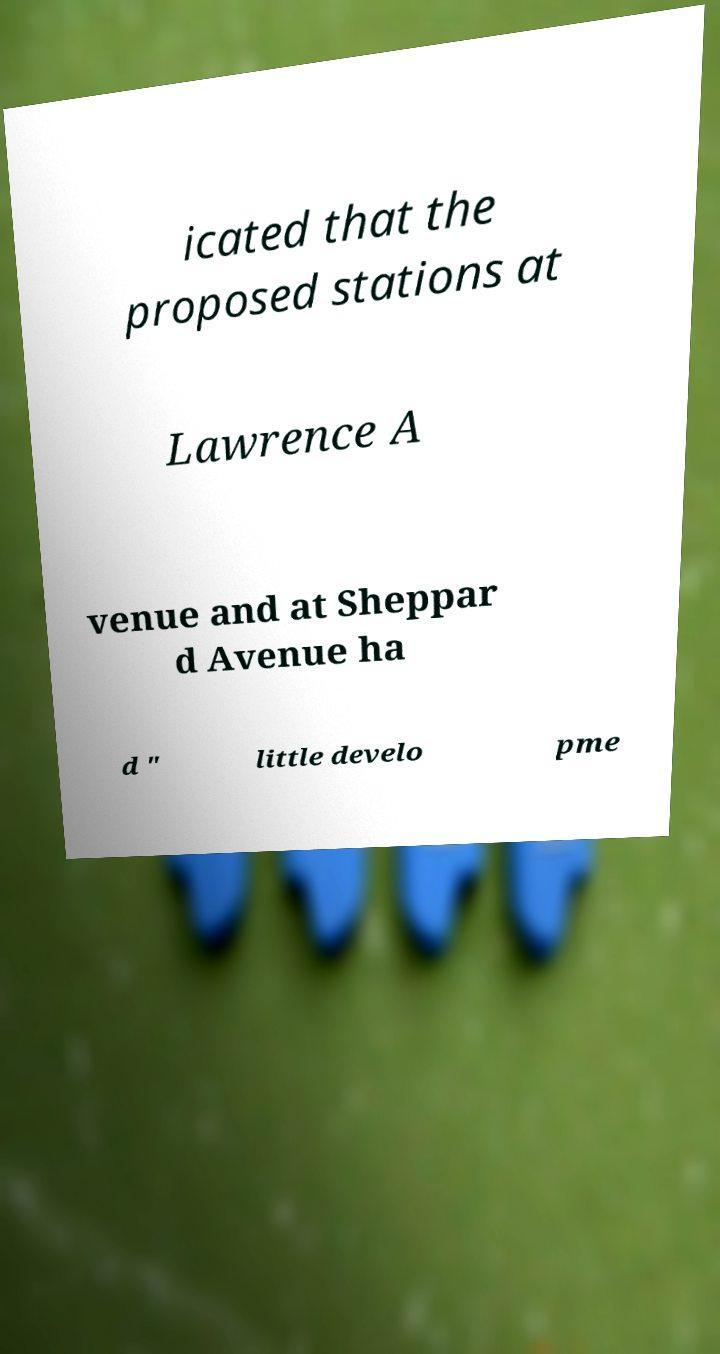Could you assist in decoding the text presented in this image and type it out clearly? icated that the proposed stations at Lawrence A venue and at Sheppar d Avenue ha d " little develo pme 